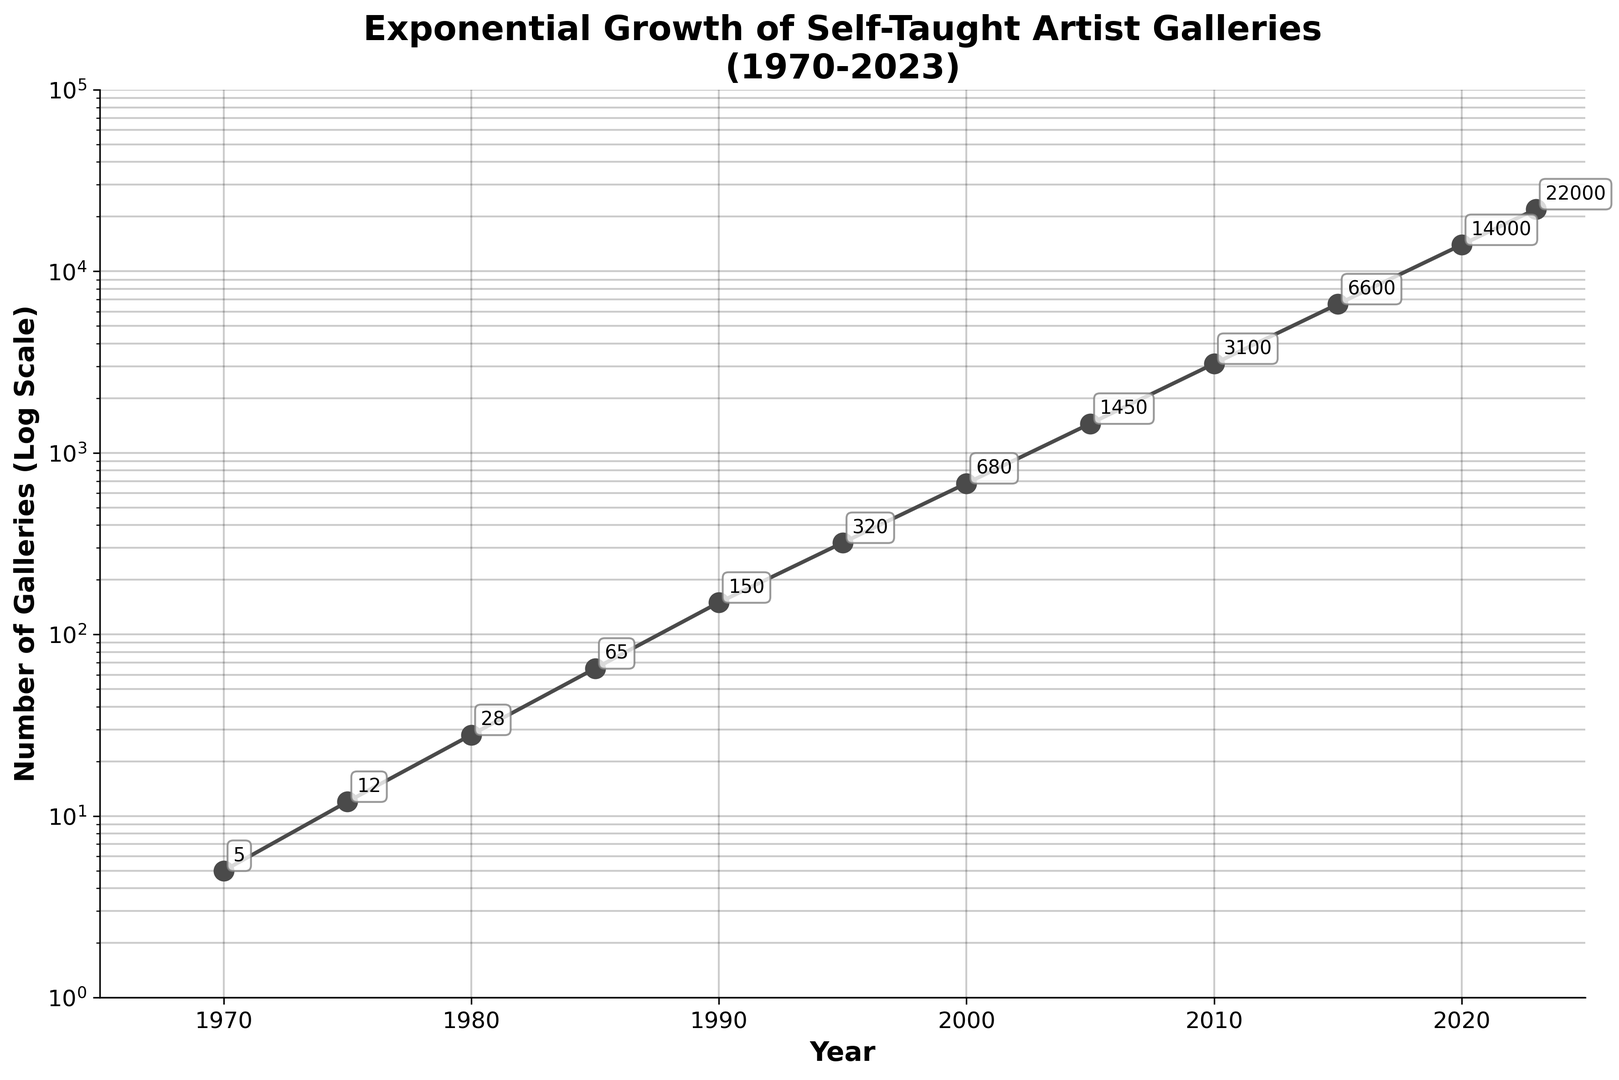What year did the number of galleries first exceed 1000? The log scale shows an exponential increase in the number of galleries, with labels marking important milestones. Look closely at each milestone to determine where the count surpasses 1000.
Answer: 2000 Which year had the steepest increase in the number of galleries? Examine the slope of the line on the log scale. The year corresponding to the steepest part of the curve represents the largest year-over-year increase.
Answer: 2000-2005 What is the difference in the number of galleries between 1995 and 2005? Look at the annotated numbers for 1995 and 2005. Subtract the number of galleries in 1995 from that in 2005 to find the difference.
Answer: 1130 How many galleries were there in 1985 compared to 1970? Look at the values annotated for the years 1985 and 1970 and compare them directly.
Answer: 1985 had 60 more galleries than 1970 Is the number of galleries doubling every 5 years? Check multiple consecutive 5-year intervals and see if the numbers roughly double: 1970-1975, 1975-1980, etc. For instance, from 1985 (65) to 1990 (150), it does not exactly double.
Answer: No During which decade did the number of galleries surpass 100? Identify on the x-axis where the number of galleries exceeded 100 by looking at the corresponding decade.
Answer: 1980-1990 What is the average rate of increase in the number of galleries between 2000 and 2010? Calculate the total increase in the number of galleries between 2000 and 2010 and then divide by the number of years (10). Increase = 3100 - 680 = 2420. Average rate = 2420/10.
Answer: 242/year How does the visual representation of the number of galleries in 2023 compare to 1990 on the log scale? Notice the height difference between the markers for 1990 and 2023 on the semi-logarithmic scale. Since it's a log scale, the difference appears as an entire order of magnitude.
Answer: Much higher in 2023 What trend can you observe about the growth rate of art galleries after 2000? By analyzing the log-scaled curve after 2000, note that the steepness of the curve increases significantly, indicating a higher growth rate.
Answer: Accelerated growth How many years did it take for the number of galleries to grow from approximately 150 to 14,000? Look at the years associated with these two values. Note that 150 galleries occurred in 1990 and 14,000 in 2020.
Answer: 30 years 